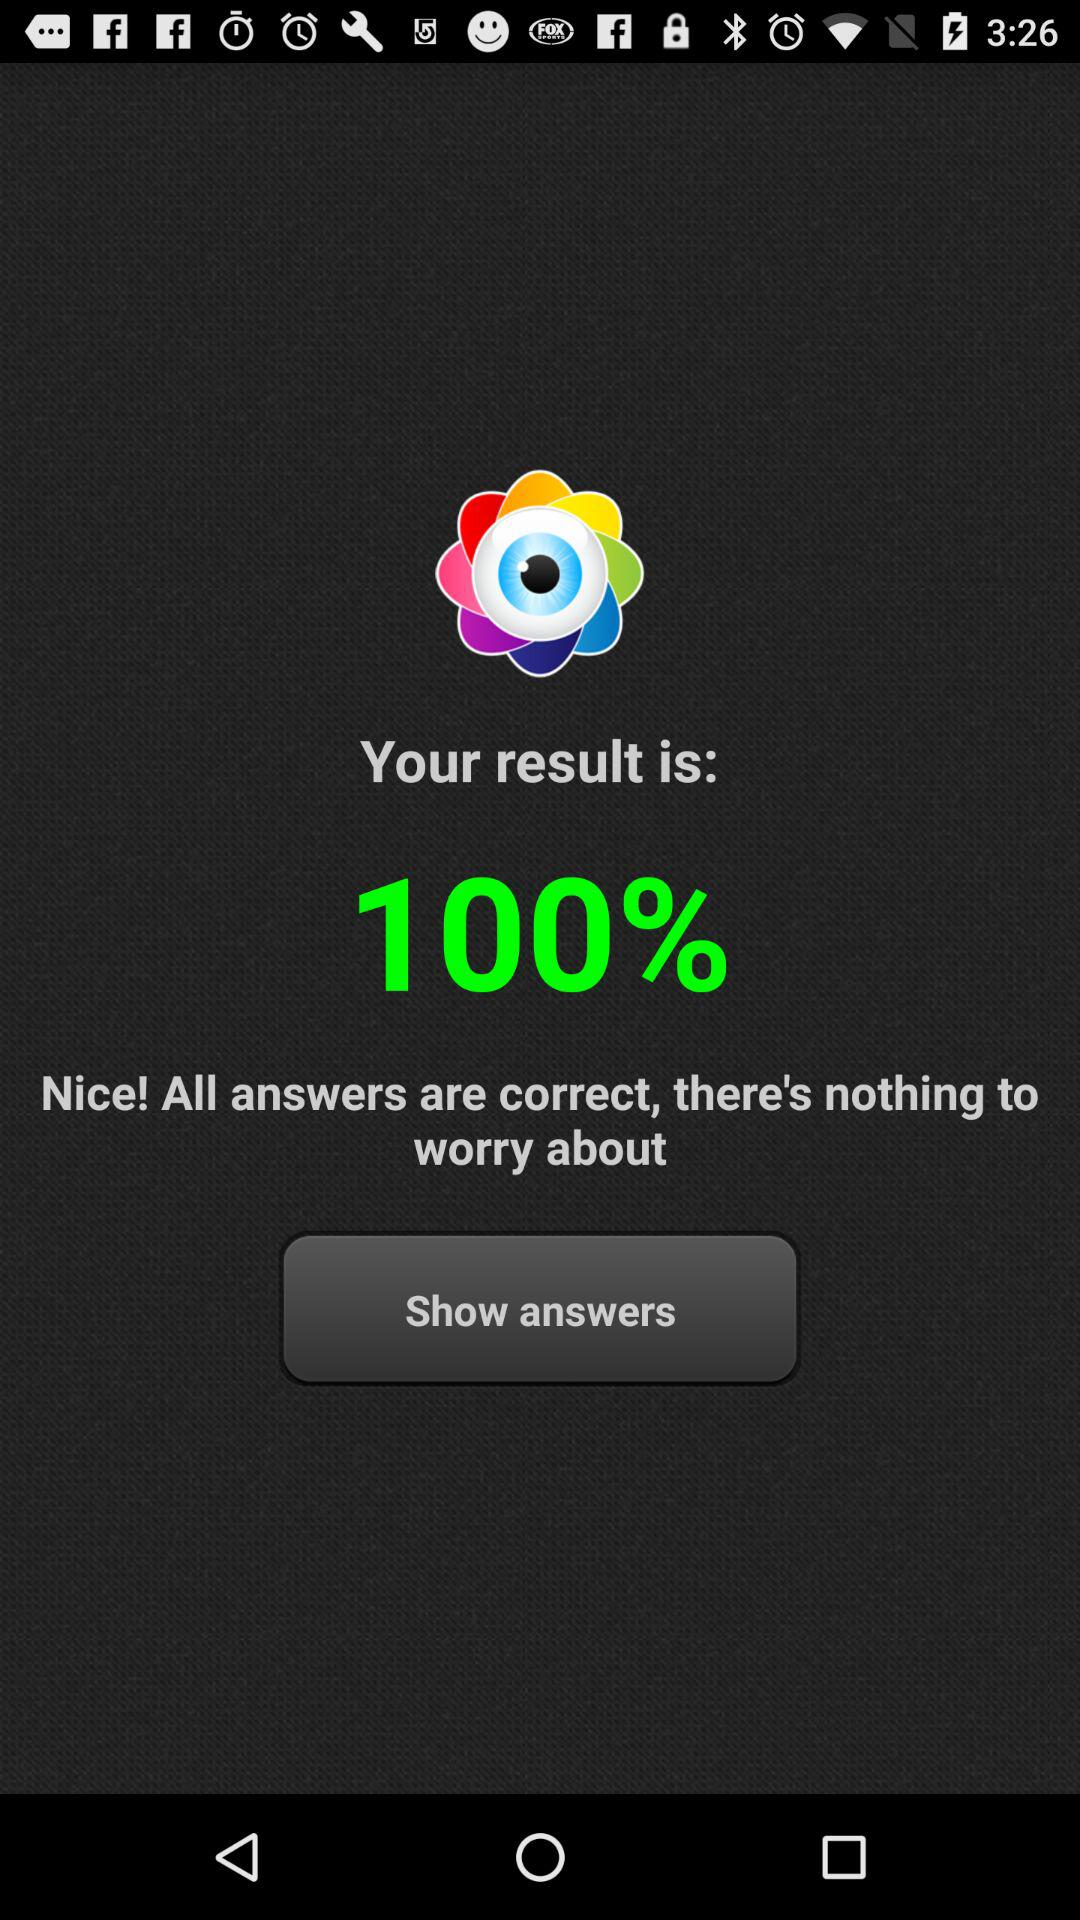What is the percentage of the score?
Answer the question using a single word or phrase. 100% 